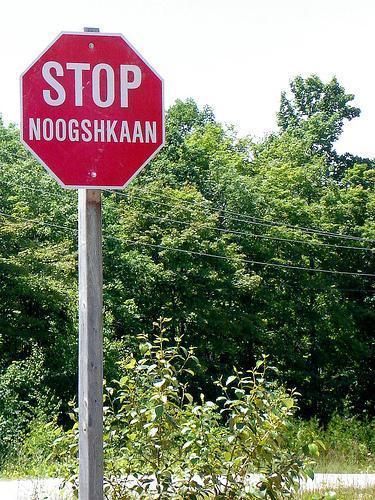How many signs are there?
Give a very brief answer. 1. How many blue signs are in the image?
Give a very brief answer. 0. 